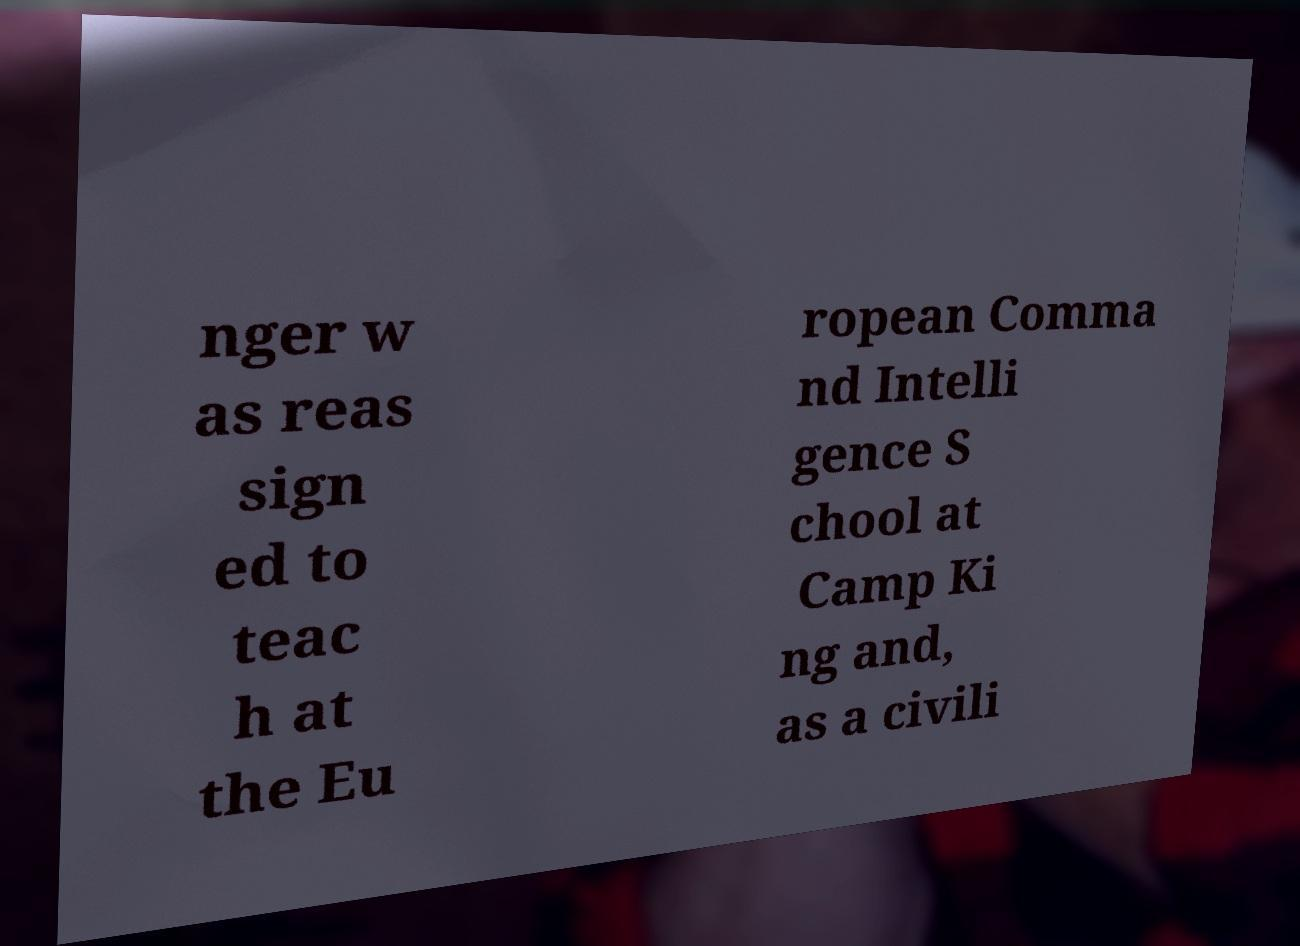There's text embedded in this image that I need extracted. Can you transcribe it verbatim? nger w as reas sign ed to teac h at the Eu ropean Comma nd Intelli gence S chool at Camp Ki ng and, as a civili 